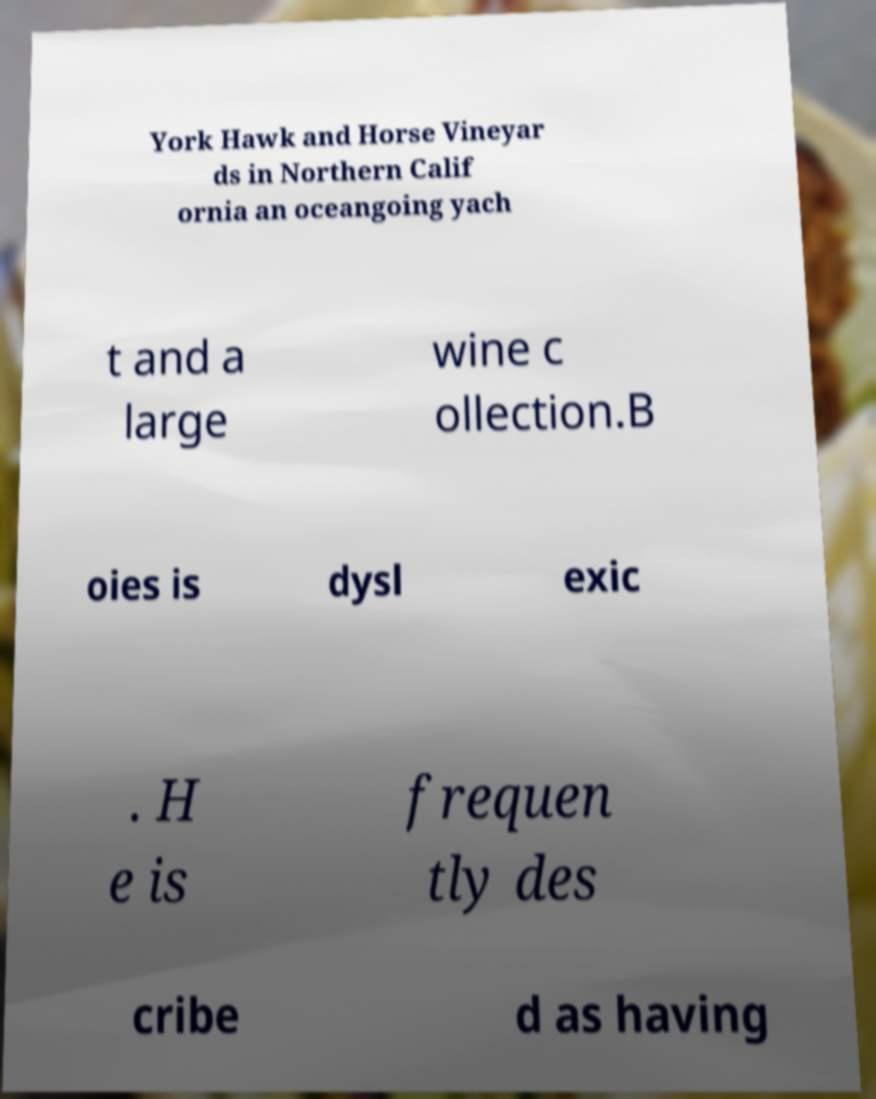There's text embedded in this image that I need extracted. Can you transcribe it verbatim? York Hawk and Horse Vineyar ds in Northern Calif ornia an oceangoing yach t and a large wine c ollection.B oies is dysl exic . H e is frequen tly des cribe d as having 